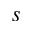<formula> <loc_0><loc_0><loc_500><loc_500>s</formula> 